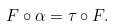<formula> <loc_0><loc_0><loc_500><loc_500>F \circ \alpha = \tau \circ F .</formula> 